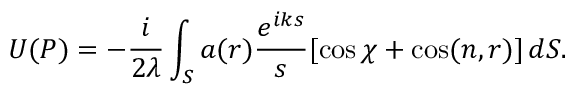Convert formula to latex. <formula><loc_0><loc_0><loc_500><loc_500>U ( P ) = - { \frac { i } { 2 \lambda } } \int _ { S } a ( r ) { \frac { e ^ { i k s } } { s } } [ \cos \chi + \cos ( n , r ) ] \, d S .</formula> 